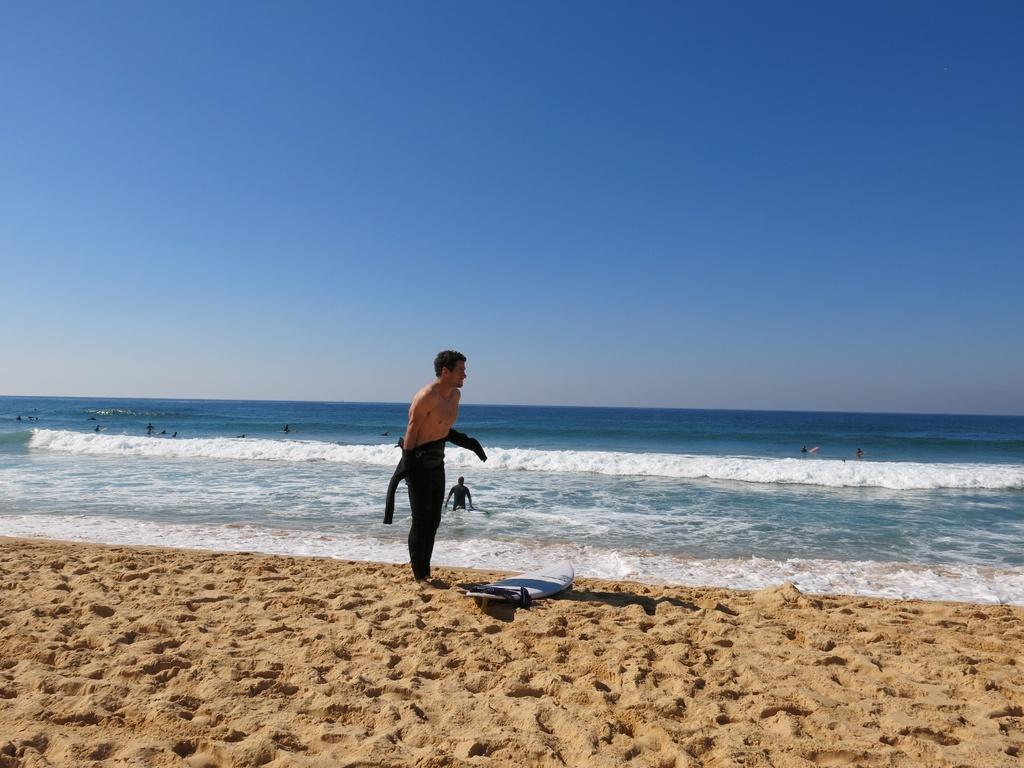Could you give a brief overview of what you see in this image? In this image there is a person standing on the land having a surfboard. There are people in the water having tides. Top of the image there is sky. 